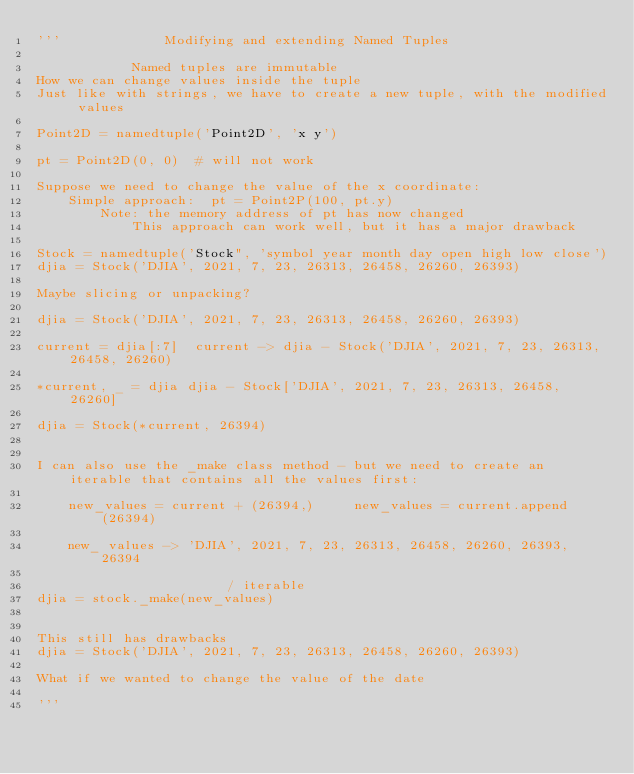<code> <loc_0><loc_0><loc_500><loc_500><_Python_>'''             Modifying and extending Named Tuples

            Named tuples are immutable
How we can change values inside the tuple
Just like with strings, we have to create a new tuple, with the modified values

Point2D = namedtuple('Point2D', 'x y')

pt = Point2D(0, 0)  # will not work

Suppose we need to change the value of the x coordinate:
    Simple approach:  pt = Point2P(100, pt.y)
        Note: the memory address of pt has now changed
            This approach can work well, but it has a major drawback

Stock = namedtuple('Stock", 'symbol year month day open high low close')
djia = Stock('DJIA', 2021, 7, 23, 26313, 26458, 26260, 26393)

Maybe slicing or unpacking?

djia = Stock('DJIA', 2021, 7, 23, 26313, 26458, 26260, 26393)

current = djia[:7]  current -> djia - Stock('DJIA', 2021, 7, 23, 26313, 26458, 26260)

*current, _ = djia djia - Stock['DJIA', 2021, 7, 23, 26313, 26458, 26260]

djia = Stock(*current, 26394)


I can also use the _make class method - but we need to create an iterable that contains all the values first:

    new_values = current + (26394,)     new_values = current.append(26394)

    new_ values -> 'DJIA', 2021, 7, 23, 26313, 26458, 26260, 26393, 26394

                        / iterable
djia = stock._make(new_values)


This still has drawbacks
djia = Stock('DJIA', 2021, 7, 23, 26313, 26458, 26260, 26393)

What if we wanted to change the value of the date

'''</code> 